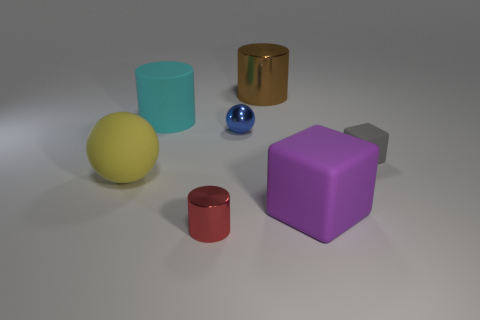Is there any other thing that has the same material as the tiny gray cube?
Your response must be concise. Yes. There is a large thing that is on the left side of the blue metal sphere and in front of the small blue ball; what material is it?
Offer a very short reply. Rubber. How many large purple rubber things are the same shape as the yellow object?
Provide a succinct answer. 0. There is a tiny shiny thing behind the metal cylinder on the left side of the brown thing; what is its color?
Offer a very short reply. Blue. Are there the same number of large yellow matte things on the left side of the big yellow thing and tiny rubber things?
Your response must be concise. No. Is there a red metal object that has the same size as the purple object?
Make the answer very short. No. Do the blue sphere and the cylinder behind the cyan rubber thing have the same size?
Your answer should be very brief. No. Are there an equal number of things that are right of the brown cylinder and cyan cylinders that are to the right of the gray cube?
Provide a short and direct response. No. What is the material of the cube behind the large purple block?
Offer a very short reply. Rubber. Is the brown metallic cylinder the same size as the red object?
Ensure brevity in your answer.  No. 